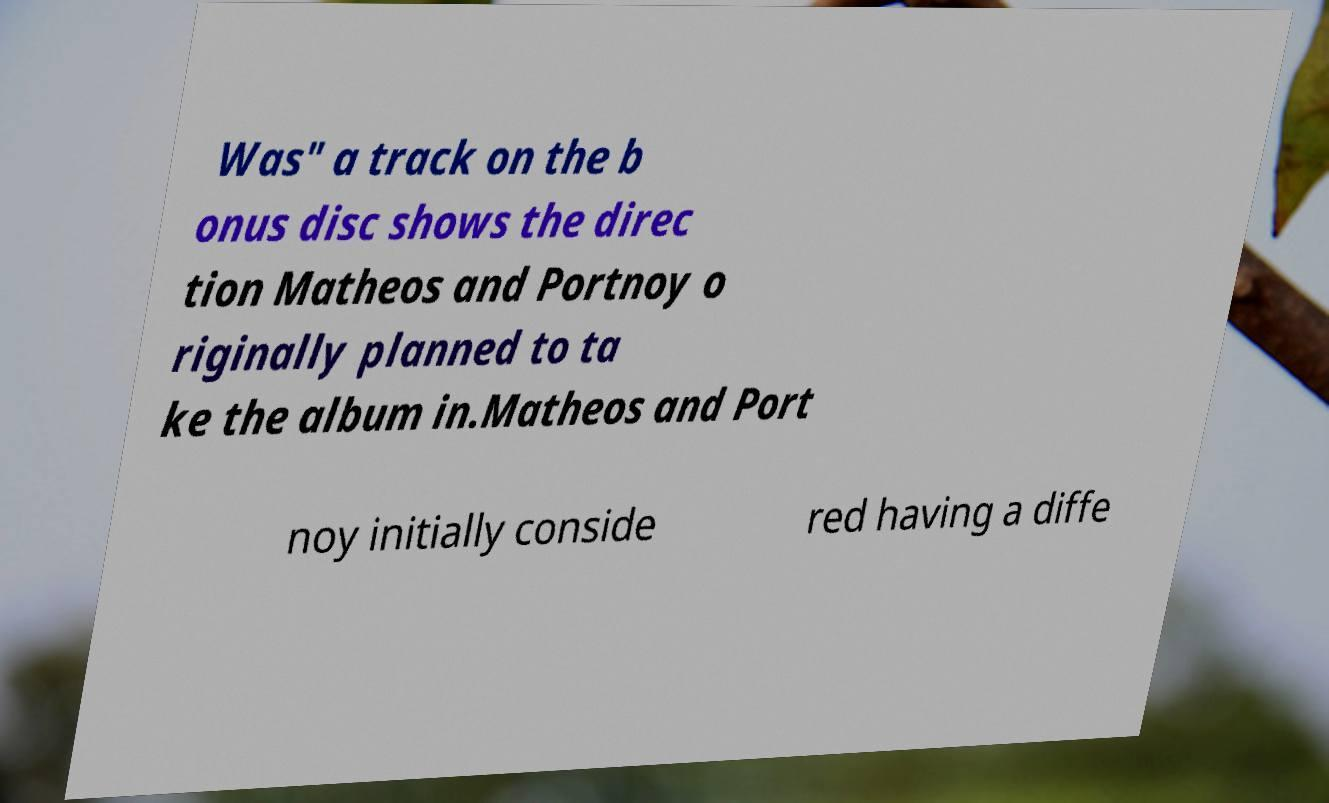Can you accurately transcribe the text from the provided image for me? Was" a track on the b onus disc shows the direc tion Matheos and Portnoy o riginally planned to ta ke the album in.Matheos and Port noy initially conside red having a diffe 